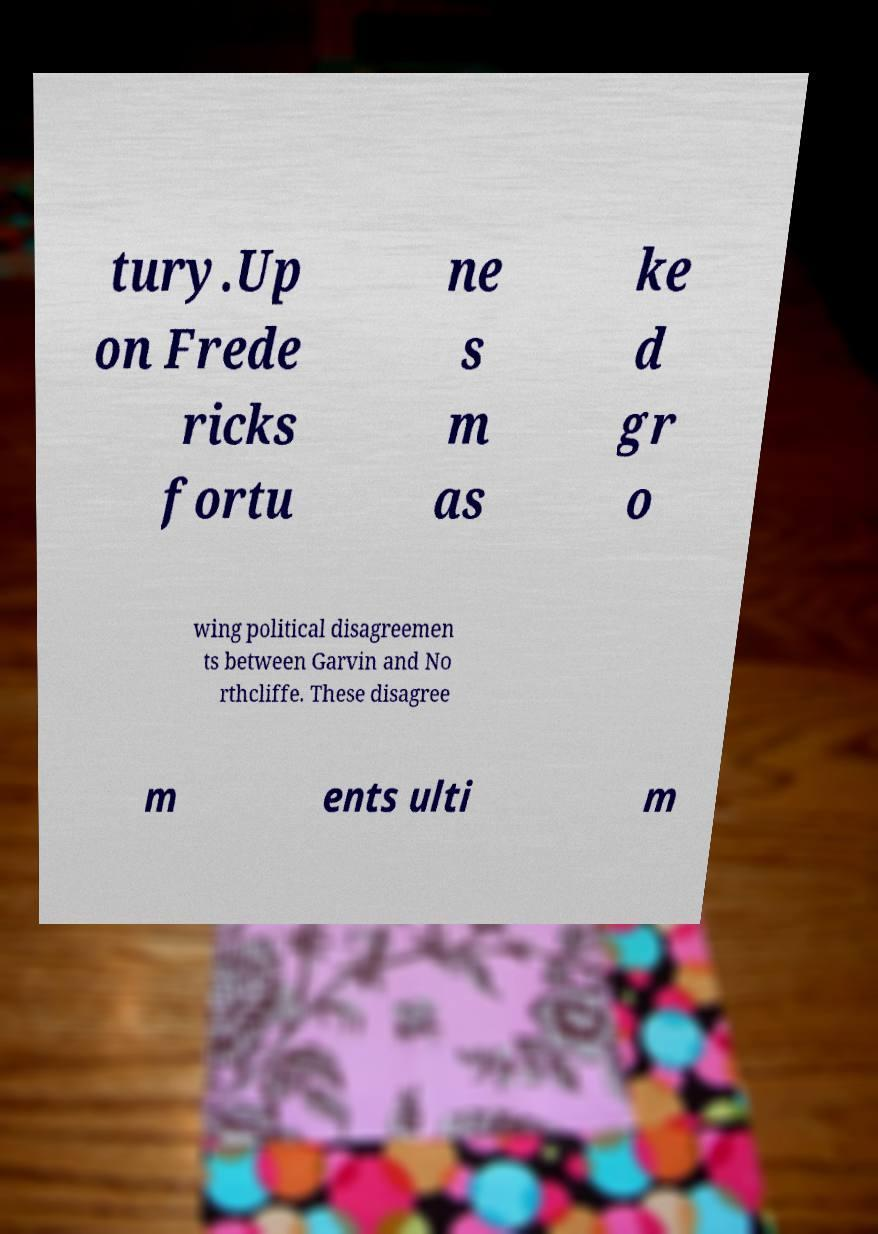I need the written content from this picture converted into text. Can you do that? tury.Up on Frede ricks fortu ne s m as ke d gr o wing political disagreemen ts between Garvin and No rthcliffe. These disagree m ents ulti m 